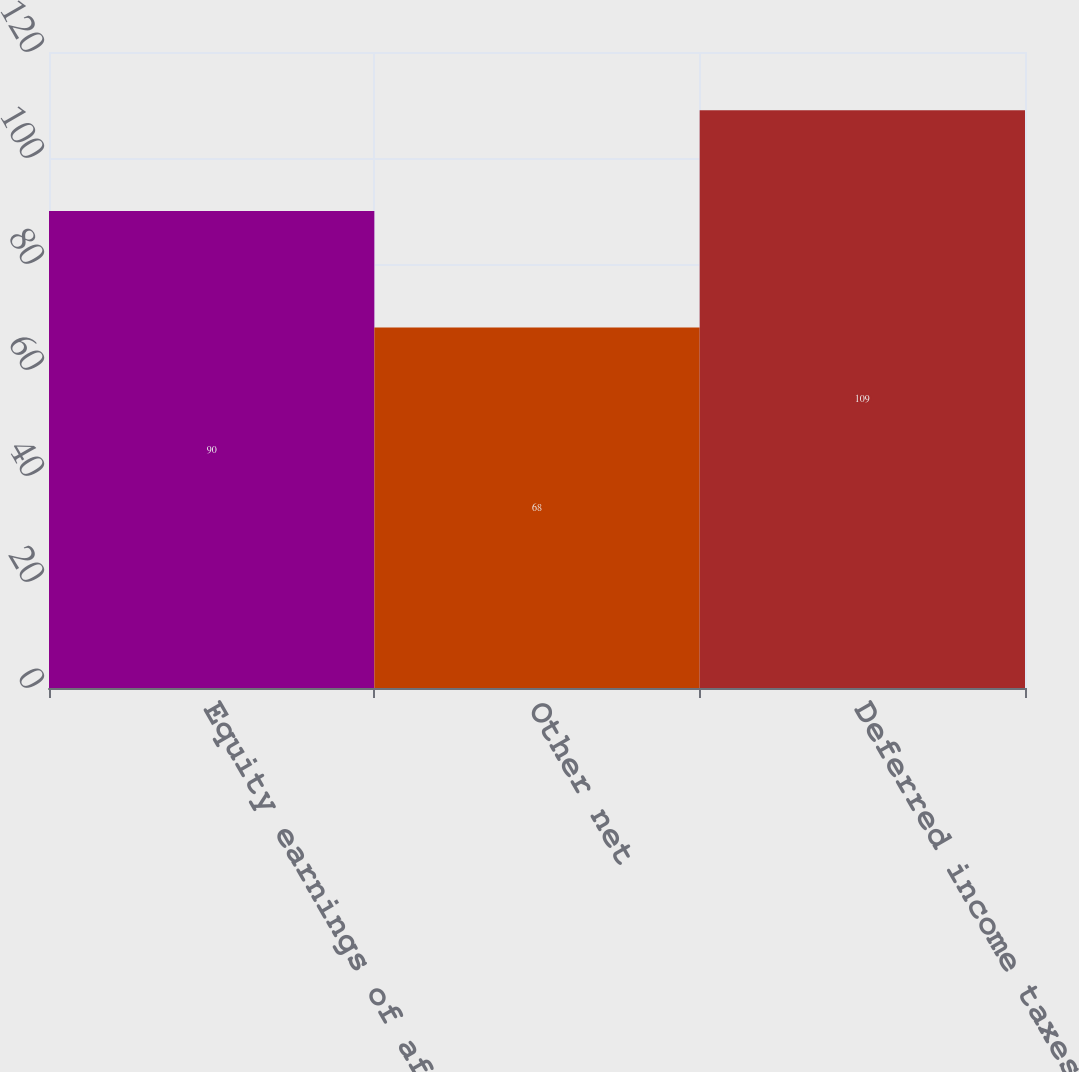<chart> <loc_0><loc_0><loc_500><loc_500><bar_chart><fcel>Equity earnings of affiliates<fcel>Other net<fcel>Deferred income taxes and<nl><fcel>90<fcel>68<fcel>109<nl></chart> 